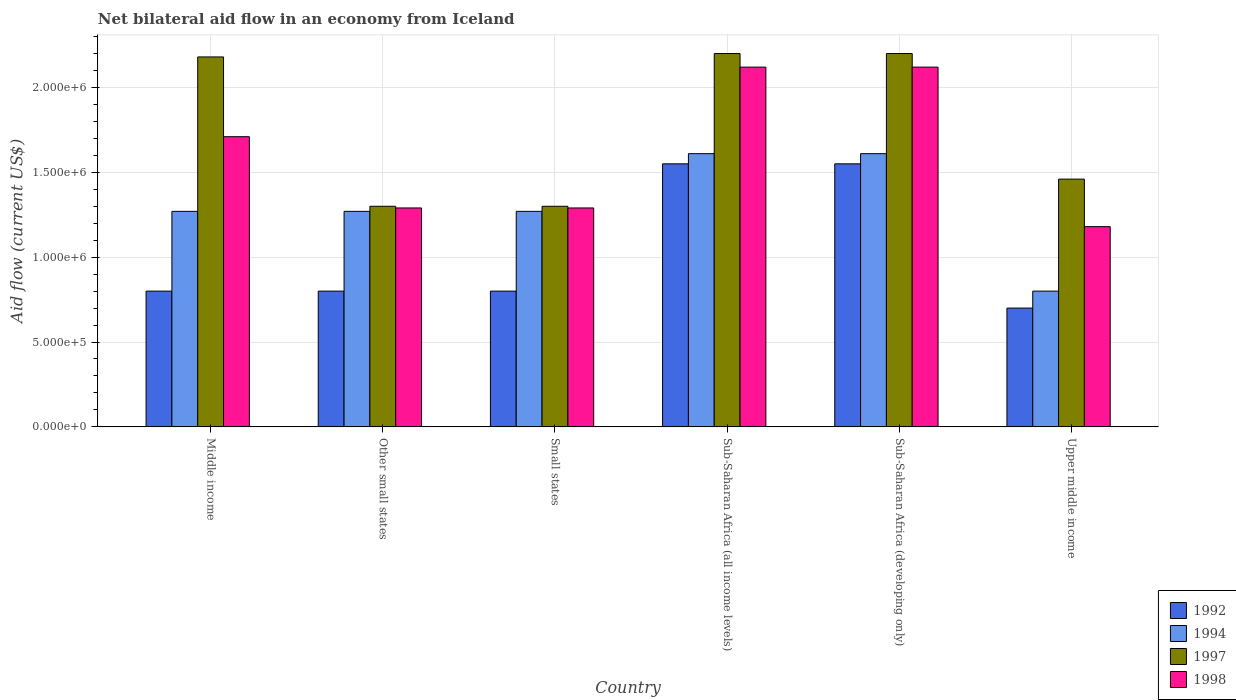How many different coloured bars are there?
Your answer should be very brief. 4. How many bars are there on the 1st tick from the right?
Your answer should be compact. 4. What is the label of the 3rd group of bars from the left?
Make the answer very short. Small states. In how many cases, is the number of bars for a given country not equal to the number of legend labels?
Your answer should be very brief. 0. What is the net bilateral aid flow in 1997 in Sub-Saharan Africa (developing only)?
Give a very brief answer. 2.20e+06. Across all countries, what is the maximum net bilateral aid flow in 1994?
Offer a very short reply. 1.61e+06. In which country was the net bilateral aid flow in 1997 maximum?
Offer a terse response. Sub-Saharan Africa (all income levels). In which country was the net bilateral aid flow in 1994 minimum?
Ensure brevity in your answer.  Upper middle income. What is the total net bilateral aid flow in 1997 in the graph?
Your answer should be compact. 1.06e+07. What is the difference between the net bilateral aid flow in 1992 in Small states and that in Sub-Saharan Africa (developing only)?
Your answer should be compact. -7.50e+05. What is the difference between the net bilateral aid flow in 1997 in Sub-Saharan Africa (all income levels) and the net bilateral aid flow in 1992 in Upper middle income?
Your answer should be compact. 1.50e+06. What is the average net bilateral aid flow in 1997 per country?
Provide a short and direct response. 1.77e+06. What is the difference between the net bilateral aid flow of/in 1992 and net bilateral aid flow of/in 1997 in Sub-Saharan Africa (all income levels)?
Ensure brevity in your answer.  -6.50e+05. What is the ratio of the net bilateral aid flow in 1997 in Middle income to that in Other small states?
Give a very brief answer. 1.68. Is the net bilateral aid flow in 1997 in Small states less than that in Upper middle income?
Offer a very short reply. Yes. What is the difference between the highest and the second highest net bilateral aid flow in 1998?
Your response must be concise. 4.10e+05. What is the difference between the highest and the lowest net bilateral aid flow in 1994?
Offer a very short reply. 8.10e+05. Is the sum of the net bilateral aid flow in 1994 in Other small states and Small states greater than the maximum net bilateral aid flow in 1997 across all countries?
Make the answer very short. Yes. Is it the case that in every country, the sum of the net bilateral aid flow in 1998 and net bilateral aid flow in 1994 is greater than the sum of net bilateral aid flow in 1992 and net bilateral aid flow in 1997?
Offer a very short reply. No. What does the 4th bar from the left in Small states represents?
Offer a very short reply. 1998. What does the 3rd bar from the right in Middle income represents?
Provide a short and direct response. 1994. How many bars are there?
Offer a very short reply. 24. Are all the bars in the graph horizontal?
Make the answer very short. No. Are the values on the major ticks of Y-axis written in scientific E-notation?
Your response must be concise. Yes. Does the graph contain grids?
Your response must be concise. Yes. How are the legend labels stacked?
Your answer should be very brief. Vertical. What is the title of the graph?
Your answer should be compact. Net bilateral aid flow in an economy from Iceland. Does "1990" appear as one of the legend labels in the graph?
Provide a succinct answer. No. What is the Aid flow (current US$) of 1994 in Middle income?
Provide a short and direct response. 1.27e+06. What is the Aid flow (current US$) of 1997 in Middle income?
Ensure brevity in your answer.  2.18e+06. What is the Aid flow (current US$) of 1998 in Middle income?
Provide a short and direct response. 1.71e+06. What is the Aid flow (current US$) of 1994 in Other small states?
Your answer should be very brief. 1.27e+06. What is the Aid flow (current US$) in 1997 in Other small states?
Provide a succinct answer. 1.30e+06. What is the Aid flow (current US$) of 1998 in Other small states?
Give a very brief answer. 1.29e+06. What is the Aid flow (current US$) in 1994 in Small states?
Keep it short and to the point. 1.27e+06. What is the Aid flow (current US$) in 1997 in Small states?
Your response must be concise. 1.30e+06. What is the Aid flow (current US$) of 1998 in Small states?
Offer a very short reply. 1.29e+06. What is the Aid flow (current US$) of 1992 in Sub-Saharan Africa (all income levels)?
Your answer should be compact. 1.55e+06. What is the Aid flow (current US$) in 1994 in Sub-Saharan Africa (all income levels)?
Keep it short and to the point. 1.61e+06. What is the Aid flow (current US$) of 1997 in Sub-Saharan Africa (all income levels)?
Your response must be concise. 2.20e+06. What is the Aid flow (current US$) in 1998 in Sub-Saharan Africa (all income levels)?
Give a very brief answer. 2.12e+06. What is the Aid flow (current US$) in 1992 in Sub-Saharan Africa (developing only)?
Your answer should be very brief. 1.55e+06. What is the Aid flow (current US$) of 1994 in Sub-Saharan Africa (developing only)?
Provide a succinct answer. 1.61e+06. What is the Aid flow (current US$) of 1997 in Sub-Saharan Africa (developing only)?
Offer a very short reply. 2.20e+06. What is the Aid flow (current US$) of 1998 in Sub-Saharan Africa (developing only)?
Offer a terse response. 2.12e+06. What is the Aid flow (current US$) of 1992 in Upper middle income?
Provide a short and direct response. 7.00e+05. What is the Aid flow (current US$) of 1994 in Upper middle income?
Give a very brief answer. 8.00e+05. What is the Aid flow (current US$) of 1997 in Upper middle income?
Provide a short and direct response. 1.46e+06. What is the Aid flow (current US$) of 1998 in Upper middle income?
Ensure brevity in your answer.  1.18e+06. Across all countries, what is the maximum Aid flow (current US$) in 1992?
Keep it short and to the point. 1.55e+06. Across all countries, what is the maximum Aid flow (current US$) of 1994?
Provide a short and direct response. 1.61e+06. Across all countries, what is the maximum Aid flow (current US$) of 1997?
Provide a succinct answer. 2.20e+06. Across all countries, what is the maximum Aid flow (current US$) of 1998?
Your answer should be very brief. 2.12e+06. Across all countries, what is the minimum Aid flow (current US$) of 1992?
Offer a terse response. 7.00e+05. Across all countries, what is the minimum Aid flow (current US$) in 1997?
Offer a terse response. 1.30e+06. Across all countries, what is the minimum Aid flow (current US$) in 1998?
Provide a succinct answer. 1.18e+06. What is the total Aid flow (current US$) in 1992 in the graph?
Give a very brief answer. 6.20e+06. What is the total Aid flow (current US$) of 1994 in the graph?
Make the answer very short. 7.83e+06. What is the total Aid flow (current US$) of 1997 in the graph?
Your response must be concise. 1.06e+07. What is the total Aid flow (current US$) of 1998 in the graph?
Provide a succinct answer. 9.71e+06. What is the difference between the Aid flow (current US$) in 1992 in Middle income and that in Other small states?
Offer a very short reply. 0. What is the difference between the Aid flow (current US$) of 1997 in Middle income and that in Other small states?
Provide a short and direct response. 8.80e+05. What is the difference between the Aid flow (current US$) in 1997 in Middle income and that in Small states?
Your response must be concise. 8.80e+05. What is the difference between the Aid flow (current US$) of 1992 in Middle income and that in Sub-Saharan Africa (all income levels)?
Provide a succinct answer. -7.50e+05. What is the difference between the Aid flow (current US$) of 1998 in Middle income and that in Sub-Saharan Africa (all income levels)?
Keep it short and to the point. -4.10e+05. What is the difference between the Aid flow (current US$) of 1992 in Middle income and that in Sub-Saharan Africa (developing only)?
Your answer should be compact. -7.50e+05. What is the difference between the Aid flow (current US$) of 1997 in Middle income and that in Sub-Saharan Africa (developing only)?
Keep it short and to the point. -2.00e+04. What is the difference between the Aid flow (current US$) of 1998 in Middle income and that in Sub-Saharan Africa (developing only)?
Your answer should be compact. -4.10e+05. What is the difference between the Aid flow (current US$) in 1992 in Middle income and that in Upper middle income?
Your response must be concise. 1.00e+05. What is the difference between the Aid flow (current US$) of 1994 in Middle income and that in Upper middle income?
Provide a succinct answer. 4.70e+05. What is the difference between the Aid flow (current US$) in 1997 in Middle income and that in Upper middle income?
Your response must be concise. 7.20e+05. What is the difference between the Aid flow (current US$) of 1998 in Middle income and that in Upper middle income?
Provide a succinct answer. 5.30e+05. What is the difference between the Aid flow (current US$) in 1994 in Other small states and that in Small states?
Keep it short and to the point. 0. What is the difference between the Aid flow (current US$) in 1997 in Other small states and that in Small states?
Give a very brief answer. 0. What is the difference between the Aid flow (current US$) in 1998 in Other small states and that in Small states?
Provide a succinct answer. 0. What is the difference between the Aid flow (current US$) of 1992 in Other small states and that in Sub-Saharan Africa (all income levels)?
Provide a short and direct response. -7.50e+05. What is the difference between the Aid flow (current US$) in 1997 in Other small states and that in Sub-Saharan Africa (all income levels)?
Provide a short and direct response. -9.00e+05. What is the difference between the Aid flow (current US$) in 1998 in Other small states and that in Sub-Saharan Africa (all income levels)?
Make the answer very short. -8.30e+05. What is the difference between the Aid flow (current US$) in 1992 in Other small states and that in Sub-Saharan Africa (developing only)?
Provide a succinct answer. -7.50e+05. What is the difference between the Aid flow (current US$) in 1997 in Other small states and that in Sub-Saharan Africa (developing only)?
Give a very brief answer. -9.00e+05. What is the difference between the Aid flow (current US$) in 1998 in Other small states and that in Sub-Saharan Africa (developing only)?
Offer a very short reply. -8.30e+05. What is the difference between the Aid flow (current US$) of 1992 in Other small states and that in Upper middle income?
Give a very brief answer. 1.00e+05. What is the difference between the Aid flow (current US$) of 1994 in Other small states and that in Upper middle income?
Your response must be concise. 4.70e+05. What is the difference between the Aid flow (current US$) in 1997 in Other small states and that in Upper middle income?
Give a very brief answer. -1.60e+05. What is the difference between the Aid flow (current US$) in 1998 in Other small states and that in Upper middle income?
Offer a very short reply. 1.10e+05. What is the difference between the Aid flow (current US$) of 1992 in Small states and that in Sub-Saharan Africa (all income levels)?
Provide a succinct answer. -7.50e+05. What is the difference between the Aid flow (current US$) of 1994 in Small states and that in Sub-Saharan Africa (all income levels)?
Keep it short and to the point. -3.40e+05. What is the difference between the Aid flow (current US$) of 1997 in Small states and that in Sub-Saharan Africa (all income levels)?
Make the answer very short. -9.00e+05. What is the difference between the Aid flow (current US$) in 1998 in Small states and that in Sub-Saharan Africa (all income levels)?
Provide a succinct answer. -8.30e+05. What is the difference between the Aid flow (current US$) in 1992 in Small states and that in Sub-Saharan Africa (developing only)?
Keep it short and to the point. -7.50e+05. What is the difference between the Aid flow (current US$) in 1994 in Small states and that in Sub-Saharan Africa (developing only)?
Make the answer very short. -3.40e+05. What is the difference between the Aid flow (current US$) in 1997 in Small states and that in Sub-Saharan Africa (developing only)?
Your response must be concise. -9.00e+05. What is the difference between the Aid flow (current US$) of 1998 in Small states and that in Sub-Saharan Africa (developing only)?
Give a very brief answer. -8.30e+05. What is the difference between the Aid flow (current US$) of 1998 in Small states and that in Upper middle income?
Make the answer very short. 1.10e+05. What is the difference between the Aid flow (current US$) of 1992 in Sub-Saharan Africa (all income levels) and that in Sub-Saharan Africa (developing only)?
Your answer should be very brief. 0. What is the difference between the Aid flow (current US$) in 1994 in Sub-Saharan Africa (all income levels) and that in Sub-Saharan Africa (developing only)?
Make the answer very short. 0. What is the difference between the Aid flow (current US$) in 1997 in Sub-Saharan Africa (all income levels) and that in Sub-Saharan Africa (developing only)?
Make the answer very short. 0. What is the difference between the Aid flow (current US$) in 1992 in Sub-Saharan Africa (all income levels) and that in Upper middle income?
Offer a terse response. 8.50e+05. What is the difference between the Aid flow (current US$) of 1994 in Sub-Saharan Africa (all income levels) and that in Upper middle income?
Make the answer very short. 8.10e+05. What is the difference between the Aid flow (current US$) in 1997 in Sub-Saharan Africa (all income levels) and that in Upper middle income?
Provide a short and direct response. 7.40e+05. What is the difference between the Aid flow (current US$) of 1998 in Sub-Saharan Africa (all income levels) and that in Upper middle income?
Ensure brevity in your answer.  9.40e+05. What is the difference between the Aid flow (current US$) of 1992 in Sub-Saharan Africa (developing only) and that in Upper middle income?
Offer a very short reply. 8.50e+05. What is the difference between the Aid flow (current US$) in 1994 in Sub-Saharan Africa (developing only) and that in Upper middle income?
Your response must be concise. 8.10e+05. What is the difference between the Aid flow (current US$) in 1997 in Sub-Saharan Africa (developing only) and that in Upper middle income?
Your answer should be compact. 7.40e+05. What is the difference between the Aid flow (current US$) of 1998 in Sub-Saharan Africa (developing only) and that in Upper middle income?
Your answer should be very brief. 9.40e+05. What is the difference between the Aid flow (current US$) in 1992 in Middle income and the Aid flow (current US$) in 1994 in Other small states?
Keep it short and to the point. -4.70e+05. What is the difference between the Aid flow (current US$) in 1992 in Middle income and the Aid flow (current US$) in 1997 in Other small states?
Ensure brevity in your answer.  -5.00e+05. What is the difference between the Aid flow (current US$) in 1992 in Middle income and the Aid flow (current US$) in 1998 in Other small states?
Offer a very short reply. -4.90e+05. What is the difference between the Aid flow (current US$) of 1994 in Middle income and the Aid flow (current US$) of 1997 in Other small states?
Make the answer very short. -3.00e+04. What is the difference between the Aid flow (current US$) of 1994 in Middle income and the Aid flow (current US$) of 1998 in Other small states?
Offer a terse response. -2.00e+04. What is the difference between the Aid flow (current US$) of 1997 in Middle income and the Aid flow (current US$) of 1998 in Other small states?
Your answer should be compact. 8.90e+05. What is the difference between the Aid flow (current US$) in 1992 in Middle income and the Aid flow (current US$) in 1994 in Small states?
Make the answer very short. -4.70e+05. What is the difference between the Aid flow (current US$) of 1992 in Middle income and the Aid flow (current US$) of 1997 in Small states?
Your answer should be very brief. -5.00e+05. What is the difference between the Aid flow (current US$) in 1992 in Middle income and the Aid flow (current US$) in 1998 in Small states?
Your answer should be very brief. -4.90e+05. What is the difference between the Aid flow (current US$) in 1997 in Middle income and the Aid flow (current US$) in 1998 in Small states?
Make the answer very short. 8.90e+05. What is the difference between the Aid flow (current US$) of 1992 in Middle income and the Aid flow (current US$) of 1994 in Sub-Saharan Africa (all income levels)?
Provide a short and direct response. -8.10e+05. What is the difference between the Aid flow (current US$) in 1992 in Middle income and the Aid flow (current US$) in 1997 in Sub-Saharan Africa (all income levels)?
Provide a short and direct response. -1.40e+06. What is the difference between the Aid flow (current US$) of 1992 in Middle income and the Aid flow (current US$) of 1998 in Sub-Saharan Africa (all income levels)?
Your response must be concise. -1.32e+06. What is the difference between the Aid flow (current US$) of 1994 in Middle income and the Aid flow (current US$) of 1997 in Sub-Saharan Africa (all income levels)?
Your answer should be compact. -9.30e+05. What is the difference between the Aid flow (current US$) in 1994 in Middle income and the Aid flow (current US$) in 1998 in Sub-Saharan Africa (all income levels)?
Provide a short and direct response. -8.50e+05. What is the difference between the Aid flow (current US$) in 1992 in Middle income and the Aid flow (current US$) in 1994 in Sub-Saharan Africa (developing only)?
Keep it short and to the point. -8.10e+05. What is the difference between the Aid flow (current US$) of 1992 in Middle income and the Aid flow (current US$) of 1997 in Sub-Saharan Africa (developing only)?
Ensure brevity in your answer.  -1.40e+06. What is the difference between the Aid flow (current US$) of 1992 in Middle income and the Aid flow (current US$) of 1998 in Sub-Saharan Africa (developing only)?
Give a very brief answer. -1.32e+06. What is the difference between the Aid flow (current US$) in 1994 in Middle income and the Aid flow (current US$) in 1997 in Sub-Saharan Africa (developing only)?
Keep it short and to the point. -9.30e+05. What is the difference between the Aid flow (current US$) in 1994 in Middle income and the Aid flow (current US$) in 1998 in Sub-Saharan Africa (developing only)?
Ensure brevity in your answer.  -8.50e+05. What is the difference between the Aid flow (current US$) of 1992 in Middle income and the Aid flow (current US$) of 1997 in Upper middle income?
Your answer should be very brief. -6.60e+05. What is the difference between the Aid flow (current US$) of 1992 in Middle income and the Aid flow (current US$) of 1998 in Upper middle income?
Offer a very short reply. -3.80e+05. What is the difference between the Aid flow (current US$) of 1994 in Middle income and the Aid flow (current US$) of 1997 in Upper middle income?
Make the answer very short. -1.90e+05. What is the difference between the Aid flow (current US$) of 1992 in Other small states and the Aid flow (current US$) of 1994 in Small states?
Your answer should be very brief. -4.70e+05. What is the difference between the Aid flow (current US$) in 1992 in Other small states and the Aid flow (current US$) in 1997 in Small states?
Give a very brief answer. -5.00e+05. What is the difference between the Aid flow (current US$) of 1992 in Other small states and the Aid flow (current US$) of 1998 in Small states?
Provide a succinct answer. -4.90e+05. What is the difference between the Aid flow (current US$) in 1994 in Other small states and the Aid flow (current US$) in 1998 in Small states?
Provide a short and direct response. -2.00e+04. What is the difference between the Aid flow (current US$) in 1992 in Other small states and the Aid flow (current US$) in 1994 in Sub-Saharan Africa (all income levels)?
Offer a very short reply. -8.10e+05. What is the difference between the Aid flow (current US$) in 1992 in Other small states and the Aid flow (current US$) in 1997 in Sub-Saharan Africa (all income levels)?
Your answer should be compact. -1.40e+06. What is the difference between the Aid flow (current US$) in 1992 in Other small states and the Aid flow (current US$) in 1998 in Sub-Saharan Africa (all income levels)?
Your response must be concise. -1.32e+06. What is the difference between the Aid flow (current US$) in 1994 in Other small states and the Aid flow (current US$) in 1997 in Sub-Saharan Africa (all income levels)?
Offer a terse response. -9.30e+05. What is the difference between the Aid flow (current US$) of 1994 in Other small states and the Aid flow (current US$) of 1998 in Sub-Saharan Africa (all income levels)?
Your response must be concise. -8.50e+05. What is the difference between the Aid flow (current US$) of 1997 in Other small states and the Aid flow (current US$) of 1998 in Sub-Saharan Africa (all income levels)?
Make the answer very short. -8.20e+05. What is the difference between the Aid flow (current US$) of 1992 in Other small states and the Aid flow (current US$) of 1994 in Sub-Saharan Africa (developing only)?
Your answer should be very brief. -8.10e+05. What is the difference between the Aid flow (current US$) in 1992 in Other small states and the Aid flow (current US$) in 1997 in Sub-Saharan Africa (developing only)?
Offer a terse response. -1.40e+06. What is the difference between the Aid flow (current US$) of 1992 in Other small states and the Aid flow (current US$) of 1998 in Sub-Saharan Africa (developing only)?
Your response must be concise. -1.32e+06. What is the difference between the Aid flow (current US$) of 1994 in Other small states and the Aid flow (current US$) of 1997 in Sub-Saharan Africa (developing only)?
Keep it short and to the point. -9.30e+05. What is the difference between the Aid flow (current US$) of 1994 in Other small states and the Aid flow (current US$) of 1998 in Sub-Saharan Africa (developing only)?
Provide a succinct answer. -8.50e+05. What is the difference between the Aid flow (current US$) of 1997 in Other small states and the Aid flow (current US$) of 1998 in Sub-Saharan Africa (developing only)?
Offer a very short reply. -8.20e+05. What is the difference between the Aid flow (current US$) in 1992 in Other small states and the Aid flow (current US$) in 1994 in Upper middle income?
Your response must be concise. 0. What is the difference between the Aid flow (current US$) of 1992 in Other small states and the Aid flow (current US$) of 1997 in Upper middle income?
Provide a short and direct response. -6.60e+05. What is the difference between the Aid flow (current US$) of 1992 in Other small states and the Aid flow (current US$) of 1998 in Upper middle income?
Your answer should be very brief. -3.80e+05. What is the difference between the Aid flow (current US$) in 1997 in Other small states and the Aid flow (current US$) in 1998 in Upper middle income?
Make the answer very short. 1.20e+05. What is the difference between the Aid flow (current US$) in 1992 in Small states and the Aid flow (current US$) in 1994 in Sub-Saharan Africa (all income levels)?
Your response must be concise. -8.10e+05. What is the difference between the Aid flow (current US$) in 1992 in Small states and the Aid flow (current US$) in 1997 in Sub-Saharan Africa (all income levels)?
Your answer should be very brief. -1.40e+06. What is the difference between the Aid flow (current US$) in 1992 in Small states and the Aid flow (current US$) in 1998 in Sub-Saharan Africa (all income levels)?
Give a very brief answer. -1.32e+06. What is the difference between the Aid flow (current US$) of 1994 in Small states and the Aid flow (current US$) of 1997 in Sub-Saharan Africa (all income levels)?
Your response must be concise. -9.30e+05. What is the difference between the Aid flow (current US$) in 1994 in Small states and the Aid flow (current US$) in 1998 in Sub-Saharan Africa (all income levels)?
Provide a succinct answer. -8.50e+05. What is the difference between the Aid flow (current US$) of 1997 in Small states and the Aid flow (current US$) of 1998 in Sub-Saharan Africa (all income levels)?
Make the answer very short. -8.20e+05. What is the difference between the Aid flow (current US$) in 1992 in Small states and the Aid flow (current US$) in 1994 in Sub-Saharan Africa (developing only)?
Your answer should be compact. -8.10e+05. What is the difference between the Aid flow (current US$) in 1992 in Small states and the Aid flow (current US$) in 1997 in Sub-Saharan Africa (developing only)?
Keep it short and to the point. -1.40e+06. What is the difference between the Aid flow (current US$) of 1992 in Small states and the Aid flow (current US$) of 1998 in Sub-Saharan Africa (developing only)?
Provide a short and direct response. -1.32e+06. What is the difference between the Aid flow (current US$) of 1994 in Small states and the Aid flow (current US$) of 1997 in Sub-Saharan Africa (developing only)?
Keep it short and to the point. -9.30e+05. What is the difference between the Aid flow (current US$) in 1994 in Small states and the Aid flow (current US$) in 1998 in Sub-Saharan Africa (developing only)?
Make the answer very short. -8.50e+05. What is the difference between the Aid flow (current US$) of 1997 in Small states and the Aid flow (current US$) of 1998 in Sub-Saharan Africa (developing only)?
Your answer should be very brief. -8.20e+05. What is the difference between the Aid flow (current US$) in 1992 in Small states and the Aid flow (current US$) in 1994 in Upper middle income?
Offer a terse response. 0. What is the difference between the Aid flow (current US$) in 1992 in Small states and the Aid flow (current US$) in 1997 in Upper middle income?
Keep it short and to the point. -6.60e+05. What is the difference between the Aid flow (current US$) in 1992 in Small states and the Aid flow (current US$) in 1998 in Upper middle income?
Give a very brief answer. -3.80e+05. What is the difference between the Aid flow (current US$) of 1994 in Small states and the Aid flow (current US$) of 1998 in Upper middle income?
Make the answer very short. 9.00e+04. What is the difference between the Aid flow (current US$) in 1992 in Sub-Saharan Africa (all income levels) and the Aid flow (current US$) in 1994 in Sub-Saharan Africa (developing only)?
Offer a very short reply. -6.00e+04. What is the difference between the Aid flow (current US$) in 1992 in Sub-Saharan Africa (all income levels) and the Aid flow (current US$) in 1997 in Sub-Saharan Africa (developing only)?
Make the answer very short. -6.50e+05. What is the difference between the Aid flow (current US$) of 1992 in Sub-Saharan Africa (all income levels) and the Aid flow (current US$) of 1998 in Sub-Saharan Africa (developing only)?
Your answer should be compact. -5.70e+05. What is the difference between the Aid flow (current US$) of 1994 in Sub-Saharan Africa (all income levels) and the Aid flow (current US$) of 1997 in Sub-Saharan Africa (developing only)?
Provide a short and direct response. -5.90e+05. What is the difference between the Aid flow (current US$) of 1994 in Sub-Saharan Africa (all income levels) and the Aid flow (current US$) of 1998 in Sub-Saharan Africa (developing only)?
Ensure brevity in your answer.  -5.10e+05. What is the difference between the Aid flow (current US$) of 1992 in Sub-Saharan Africa (all income levels) and the Aid flow (current US$) of 1994 in Upper middle income?
Your answer should be very brief. 7.50e+05. What is the difference between the Aid flow (current US$) of 1994 in Sub-Saharan Africa (all income levels) and the Aid flow (current US$) of 1997 in Upper middle income?
Ensure brevity in your answer.  1.50e+05. What is the difference between the Aid flow (current US$) in 1994 in Sub-Saharan Africa (all income levels) and the Aid flow (current US$) in 1998 in Upper middle income?
Offer a terse response. 4.30e+05. What is the difference between the Aid flow (current US$) in 1997 in Sub-Saharan Africa (all income levels) and the Aid flow (current US$) in 1998 in Upper middle income?
Your answer should be compact. 1.02e+06. What is the difference between the Aid flow (current US$) of 1992 in Sub-Saharan Africa (developing only) and the Aid flow (current US$) of 1994 in Upper middle income?
Your answer should be compact. 7.50e+05. What is the difference between the Aid flow (current US$) of 1992 in Sub-Saharan Africa (developing only) and the Aid flow (current US$) of 1997 in Upper middle income?
Ensure brevity in your answer.  9.00e+04. What is the difference between the Aid flow (current US$) of 1992 in Sub-Saharan Africa (developing only) and the Aid flow (current US$) of 1998 in Upper middle income?
Make the answer very short. 3.70e+05. What is the difference between the Aid flow (current US$) of 1994 in Sub-Saharan Africa (developing only) and the Aid flow (current US$) of 1997 in Upper middle income?
Make the answer very short. 1.50e+05. What is the difference between the Aid flow (current US$) of 1997 in Sub-Saharan Africa (developing only) and the Aid flow (current US$) of 1998 in Upper middle income?
Provide a short and direct response. 1.02e+06. What is the average Aid flow (current US$) of 1992 per country?
Give a very brief answer. 1.03e+06. What is the average Aid flow (current US$) in 1994 per country?
Give a very brief answer. 1.30e+06. What is the average Aid flow (current US$) of 1997 per country?
Give a very brief answer. 1.77e+06. What is the average Aid flow (current US$) of 1998 per country?
Your answer should be very brief. 1.62e+06. What is the difference between the Aid flow (current US$) of 1992 and Aid flow (current US$) of 1994 in Middle income?
Your answer should be compact. -4.70e+05. What is the difference between the Aid flow (current US$) of 1992 and Aid flow (current US$) of 1997 in Middle income?
Your response must be concise. -1.38e+06. What is the difference between the Aid flow (current US$) of 1992 and Aid flow (current US$) of 1998 in Middle income?
Your answer should be very brief. -9.10e+05. What is the difference between the Aid flow (current US$) in 1994 and Aid flow (current US$) in 1997 in Middle income?
Ensure brevity in your answer.  -9.10e+05. What is the difference between the Aid flow (current US$) of 1994 and Aid flow (current US$) of 1998 in Middle income?
Provide a succinct answer. -4.40e+05. What is the difference between the Aid flow (current US$) of 1992 and Aid flow (current US$) of 1994 in Other small states?
Make the answer very short. -4.70e+05. What is the difference between the Aid flow (current US$) in 1992 and Aid flow (current US$) in 1997 in Other small states?
Offer a terse response. -5.00e+05. What is the difference between the Aid flow (current US$) in 1992 and Aid flow (current US$) in 1998 in Other small states?
Offer a very short reply. -4.90e+05. What is the difference between the Aid flow (current US$) of 1994 and Aid flow (current US$) of 1997 in Other small states?
Provide a short and direct response. -3.00e+04. What is the difference between the Aid flow (current US$) in 1997 and Aid flow (current US$) in 1998 in Other small states?
Provide a succinct answer. 10000. What is the difference between the Aid flow (current US$) in 1992 and Aid flow (current US$) in 1994 in Small states?
Your response must be concise. -4.70e+05. What is the difference between the Aid flow (current US$) in 1992 and Aid flow (current US$) in 1997 in Small states?
Keep it short and to the point. -5.00e+05. What is the difference between the Aid flow (current US$) in 1992 and Aid flow (current US$) in 1998 in Small states?
Make the answer very short. -4.90e+05. What is the difference between the Aid flow (current US$) of 1994 and Aid flow (current US$) of 1997 in Small states?
Your answer should be compact. -3.00e+04. What is the difference between the Aid flow (current US$) of 1992 and Aid flow (current US$) of 1994 in Sub-Saharan Africa (all income levels)?
Provide a short and direct response. -6.00e+04. What is the difference between the Aid flow (current US$) of 1992 and Aid flow (current US$) of 1997 in Sub-Saharan Africa (all income levels)?
Your answer should be compact. -6.50e+05. What is the difference between the Aid flow (current US$) of 1992 and Aid flow (current US$) of 1998 in Sub-Saharan Africa (all income levels)?
Your answer should be very brief. -5.70e+05. What is the difference between the Aid flow (current US$) of 1994 and Aid flow (current US$) of 1997 in Sub-Saharan Africa (all income levels)?
Offer a terse response. -5.90e+05. What is the difference between the Aid flow (current US$) in 1994 and Aid flow (current US$) in 1998 in Sub-Saharan Africa (all income levels)?
Your answer should be compact. -5.10e+05. What is the difference between the Aid flow (current US$) in 1997 and Aid flow (current US$) in 1998 in Sub-Saharan Africa (all income levels)?
Your answer should be compact. 8.00e+04. What is the difference between the Aid flow (current US$) of 1992 and Aid flow (current US$) of 1994 in Sub-Saharan Africa (developing only)?
Your answer should be very brief. -6.00e+04. What is the difference between the Aid flow (current US$) of 1992 and Aid flow (current US$) of 1997 in Sub-Saharan Africa (developing only)?
Keep it short and to the point. -6.50e+05. What is the difference between the Aid flow (current US$) in 1992 and Aid flow (current US$) in 1998 in Sub-Saharan Africa (developing only)?
Make the answer very short. -5.70e+05. What is the difference between the Aid flow (current US$) in 1994 and Aid flow (current US$) in 1997 in Sub-Saharan Africa (developing only)?
Your response must be concise. -5.90e+05. What is the difference between the Aid flow (current US$) in 1994 and Aid flow (current US$) in 1998 in Sub-Saharan Africa (developing only)?
Provide a succinct answer. -5.10e+05. What is the difference between the Aid flow (current US$) of 1997 and Aid flow (current US$) of 1998 in Sub-Saharan Africa (developing only)?
Provide a succinct answer. 8.00e+04. What is the difference between the Aid flow (current US$) of 1992 and Aid flow (current US$) of 1997 in Upper middle income?
Provide a short and direct response. -7.60e+05. What is the difference between the Aid flow (current US$) in 1992 and Aid flow (current US$) in 1998 in Upper middle income?
Your answer should be very brief. -4.80e+05. What is the difference between the Aid flow (current US$) in 1994 and Aid flow (current US$) in 1997 in Upper middle income?
Offer a terse response. -6.60e+05. What is the difference between the Aid flow (current US$) in 1994 and Aid flow (current US$) in 1998 in Upper middle income?
Your answer should be compact. -3.80e+05. What is the difference between the Aid flow (current US$) of 1997 and Aid flow (current US$) of 1998 in Upper middle income?
Give a very brief answer. 2.80e+05. What is the ratio of the Aid flow (current US$) of 1994 in Middle income to that in Other small states?
Your answer should be compact. 1. What is the ratio of the Aid flow (current US$) in 1997 in Middle income to that in Other small states?
Offer a very short reply. 1.68. What is the ratio of the Aid flow (current US$) of 1998 in Middle income to that in Other small states?
Give a very brief answer. 1.33. What is the ratio of the Aid flow (current US$) in 1994 in Middle income to that in Small states?
Your answer should be compact. 1. What is the ratio of the Aid flow (current US$) of 1997 in Middle income to that in Small states?
Make the answer very short. 1.68. What is the ratio of the Aid flow (current US$) in 1998 in Middle income to that in Small states?
Give a very brief answer. 1.33. What is the ratio of the Aid flow (current US$) in 1992 in Middle income to that in Sub-Saharan Africa (all income levels)?
Keep it short and to the point. 0.52. What is the ratio of the Aid flow (current US$) of 1994 in Middle income to that in Sub-Saharan Africa (all income levels)?
Your answer should be compact. 0.79. What is the ratio of the Aid flow (current US$) in 1997 in Middle income to that in Sub-Saharan Africa (all income levels)?
Keep it short and to the point. 0.99. What is the ratio of the Aid flow (current US$) of 1998 in Middle income to that in Sub-Saharan Africa (all income levels)?
Offer a very short reply. 0.81. What is the ratio of the Aid flow (current US$) in 1992 in Middle income to that in Sub-Saharan Africa (developing only)?
Your response must be concise. 0.52. What is the ratio of the Aid flow (current US$) in 1994 in Middle income to that in Sub-Saharan Africa (developing only)?
Offer a very short reply. 0.79. What is the ratio of the Aid flow (current US$) of 1997 in Middle income to that in Sub-Saharan Africa (developing only)?
Give a very brief answer. 0.99. What is the ratio of the Aid flow (current US$) of 1998 in Middle income to that in Sub-Saharan Africa (developing only)?
Provide a succinct answer. 0.81. What is the ratio of the Aid flow (current US$) of 1992 in Middle income to that in Upper middle income?
Provide a short and direct response. 1.14. What is the ratio of the Aid flow (current US$) in 1994 in Middle income to that in Upper middle income?
Offer a very short reply. 1.59. What is the ratio of the Aid flow (current US$) of 1997 in Middle income to that in Upper middle income?
Your answer should be compact. 1.49. What is the ratio of the Aid flow (current US$) of 1998 in Middle income to that in Upper middle income?
Give a very brief answer. 1.45. What is the ratio of the Aid flow (current US$) of 1992 in Other small states to that in Small states?
Give a very brief answer. 1. What is the ratio of the Aid flow (current US$) of 1997 in Other small states to that in Small states?
Your answer should be very brief. 1. What is the ratio of the Aid flow (current US$) of 1998 in Other small states to that in Small states?
Your response must be concise. 1. What is the ratio of the Aid flow (current US$) in 1992 in Other small states to that in Sub-Saharan Africa (all income levels)?
Provide a short and direct response. 0.52. What is the ratio of the Aid flow (current US$) of 1994 in Other small states to that in Sub-Saharan Africa (all income levels)?
Keep it short and to the point. 0.79. What is the ratio of the Aid flow (current US$) of 1997 in Other small states to that in Sub-Saharan Africa (all income levels)?
Provide a short and direct response. 0.59. What is the ratio of the Aid flow (current US$) in 1998 in Other small states to that in Sub-Saharan Africa (all income levels)?
Keep it short and to the point. 0.61. What is the ratio of the Aid flow (current US$) in 1992 in Other small states to that in Sub-Saharan Africa (developing only)?
Provide a succinct answer. 0.52. What is the ratio of the Aid flow (current US$) in 1994 in Other small states to that in Sub-Saharan Africa (developing only)?
Your response must be concise. 0.79. What is the ratio of the Aid flow (current US$) in 1997 in Other small states to that in Sub-Saharan Africa (developing only)?
Give a very brief answer. 0.59. What is the ratio of the Aid flow (current US$) in 1998 in Other small states to that in Sub-Saharan Africa (developing only)?
Offer a very short reply. 0.61. What is the ratio of the Aid flow (current US$) in 1994 in Other small states to that in Upper middle income?
Provide a succinct answer. 1.59. What is the ratio of the Aid flow (current US$) in 1997 in Other small states to that in Upper middle income?
Offer a terse response. 0.89. What is the ratio of the Aid flow (current US$) of 1998 in Other small states to that in Upper middle income?
Offer a very short reply. 1.09. What is the ratio of the Aid flow (current US$) in 1992 in Small states to that in Sub-Saharan Africa (all income levels)?
Ensure brevity in your answer.  0.52. What is the ratio of the Aid flow (current US$) in 1994 in Small states to that in Sub-Saharan Africa (all income levels)?
Offer a very short reply. 0.79. What is the ratio of the Aid flow (current US$) of 1997 in Small states to that in Sub-Saharan Africa (all income levels)?
Your answer should be compact. 0.59. What is the ratio of the Aid flow (current US$) in 1998 in Small states to that in Sub-Saharan Africa (all income levels)?
Your answer should be very brief. 0.61. What is the ratio of the Aid flow (current US$) in 1992 in Small states to that in Sub-Saharan Africa (developing only)?
Provide a short and direct response. 0.52. What is the ratio of the Aid flow (current US$) in 1994 in Small states to that in Sub-Saharan Africa (developing only)?
Give a very brief answer. 0.79. What is the ratio of the Aid flow (current US$) in 1997 in Small states to that in Sub-Saharan Africa (developing only)?
Provide a succinct answer. 0.59. What is the ratio of the Aid flow (current US$) of 1998 in Small states to that in Sub-Saharan Africa (developing only)?
Your answer should be compact. 0.61. What is the ratio of the Aid flow (current US$) of 1992 in Small states to that in Upper middle income?
Offer a terse response. 1.14. What is the ratio of the Aid flow (current US$) of 1994 in Small states to that in Upper middle income?
Offer a terse response. 1.59. What is the ratio of the Aid flow (current US$) of 1997 in Small states to that in Upper middle income?
Offer a terse response. 0.89. What is the ratio of the Aid flow (current US$) of 1998 in Small states to that in Upper middle income?
Provide a succinct answer. 1.09. What is the ratio of the Aid flow (current US$) of 1992 in Sub-Saharan Africa (all income levels) to that in Sub-Saharan Africa (developing only)?
Make the answer very short. 1. What is the ratio of the Aid flow (current US$) in 1997 in Sub-Saharan Africa (all income levels) to that in Sub-Saharan Africa (developing only)?
Your response must be concise. 1. What is the ratio of the Aid flow (current US$) in 1992 in Sub-Saharan Africa (all income levels) to that in Upper middle income?
Your answer should be very brief. 2.21. What is the ratio of the Aid flow (current US$) of 1994 in Sub-Saharan Africa (all income levels) to that in Upper middle income?
Your response must be concise. 2.01. What is the ratio of the Aid flow (current US$) of 1997 in Sub-Saharan Africa (all income levels) to that in Upper middle income?
Offer a very short reply. 1.51. What is the ratio of the Aid flow (current US$) of 1998 in Sub-Saharan Africa (all income levels) to that in Upper middle income?
Provide a succinct answer. 1.8. What is the ratio of the Aid flow (current US$) of 1992 in Sub-Saharan Africa (developing only) to that in Upper middle income?
Your response must be concise. 2.21. What is the ratio of the Aid flow (current US$) of 1994 in Sub-Saharan Africa (developing only) to that in Upper middle income?
Provide a short and direct response. 2.01. What is the ratio of the Aid flow (current US$) of 1997 in Sub-Saharan Africa (developing only) to that in Upper middle income?
Provide a short and direct response. 1.51. What is the ratio of the Aid flow (current US$) of 1998 in Sub-Saharan Africa (developing only) to that in Upper middle income?
Make the answer very short. 1.8. What is the difference between the highest and the second highest Aid flow (current US$) of 1992?
Your response must be concise. 0. What is the difference between the highest and the second highest Aid flow (current US$) in 1994?
Make the answer very short. 0. What is the difference between the highest and the second highest Aid flow (current US$) of 1997?
Your answer should be compact. 0. What is the difference between the highest and the second highest Aid flow (current US$) of 1998?
Make the answer very short. 0. What is the difference between the highest and the lowest Aid flow (current US$) in 1992?
Ensure brevity in your answer.  8.50e+05. What is the difference between the highest and the lowest Aid flow (current US$) in 1994?
Give a very brief answer. 8.10e+05. What is the difference between the highest and the lowest Aid flow (current US$) of 1998?
Give a very brief answer. 9.40e+05. 